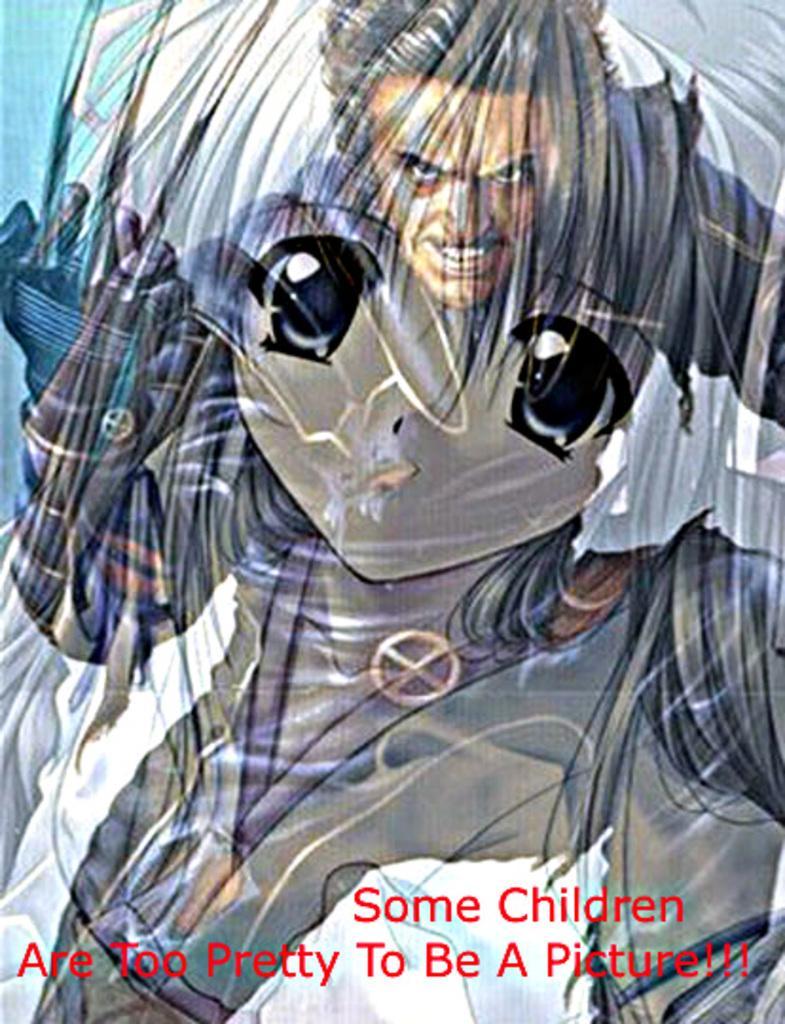In one or two sentences, can you explain what this image depicts? This is a poster,in this poster we can see a person and text. 